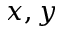<formula> <loc_0><loc_0><loc_500><loc_500>x , y</formula> 